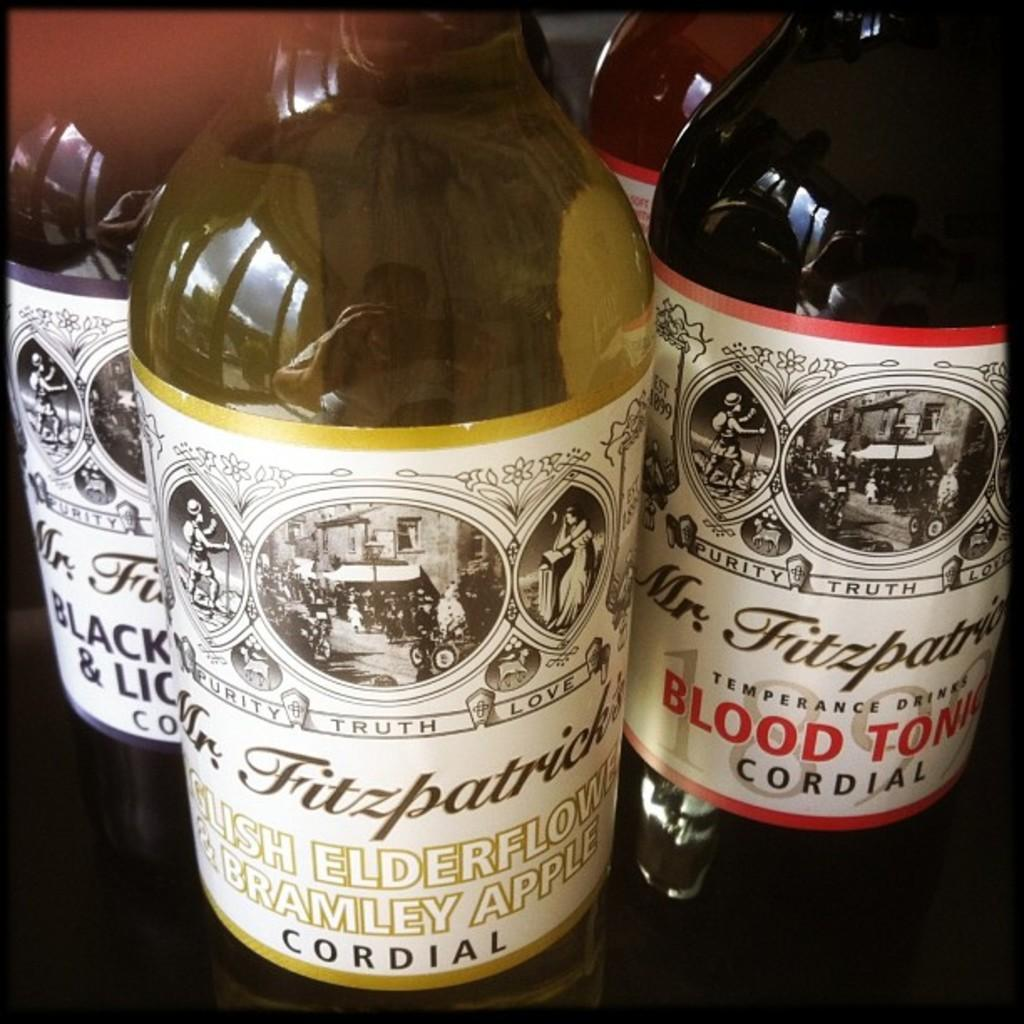<image>
Relay a brief, clear account of the picture shown. several bottles of Mr Fitzpatrick's Cordial in various flavors 